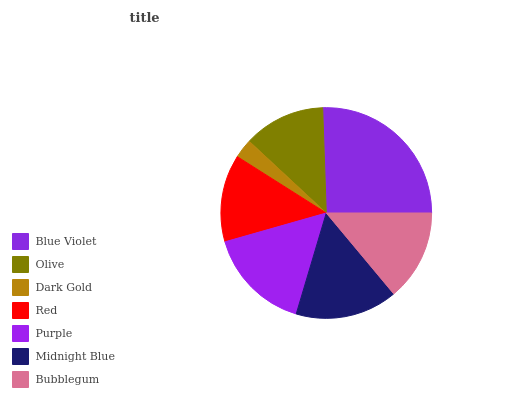Is Dark Gold the minimum?
Answer yes or no. Yes. Is Blue Violet the maximum?
Answer yes or no. Yes. Is Olive the minimum?
Answer yes or no. No. Is Olive the maximum?
Answer yes or no. No. Is Blue Violet greater than Olive?
Answer yes or no. Yes. Is Olive less than Blue Violet?
Answer yes or no. Yes. Is Olive greater than Blue Violet?
Answer yes or no. No. Is Blue Violet less than Olive?
Answer yes or no. No. Is Bubblegum the high median?
Answer yes or no. Yes. Is Bubblegum the low median?
Answer yes or no. Yes. Is Dark Gold the high median?
Answer yes or no. No. Is Dark Gold the low median?
Answer yes or no. No. 